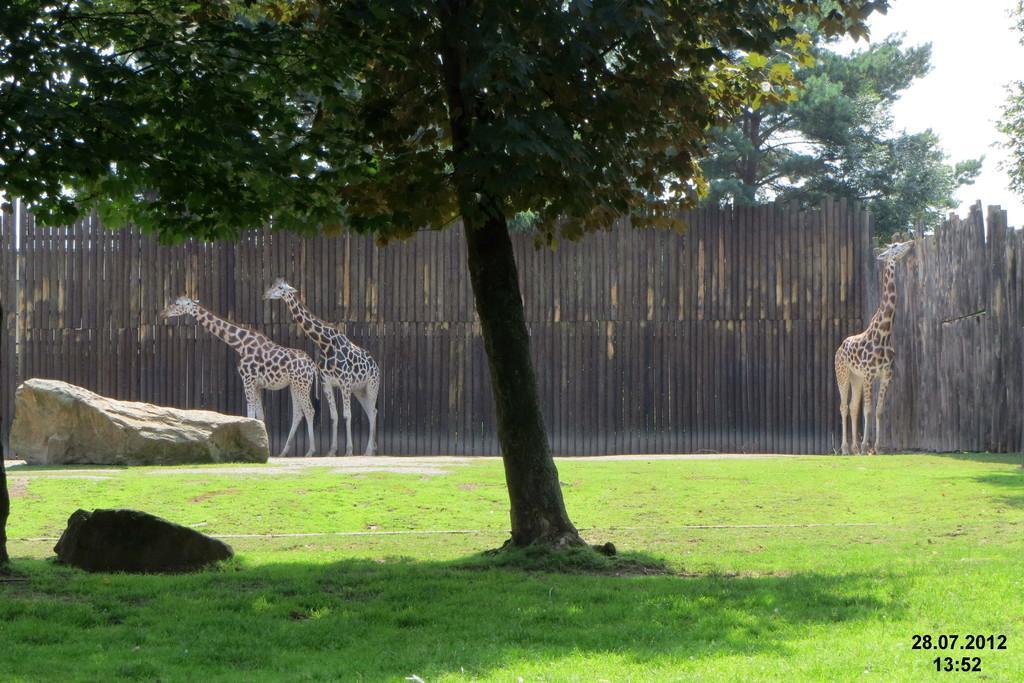Please provide a concise description of this image. The picture is taken in a zoo. In the foreground of the picture there are three, stone and grass. In the background there are giraffes, wall and a stone, outside the wall there are trees. Sky is sunny. 